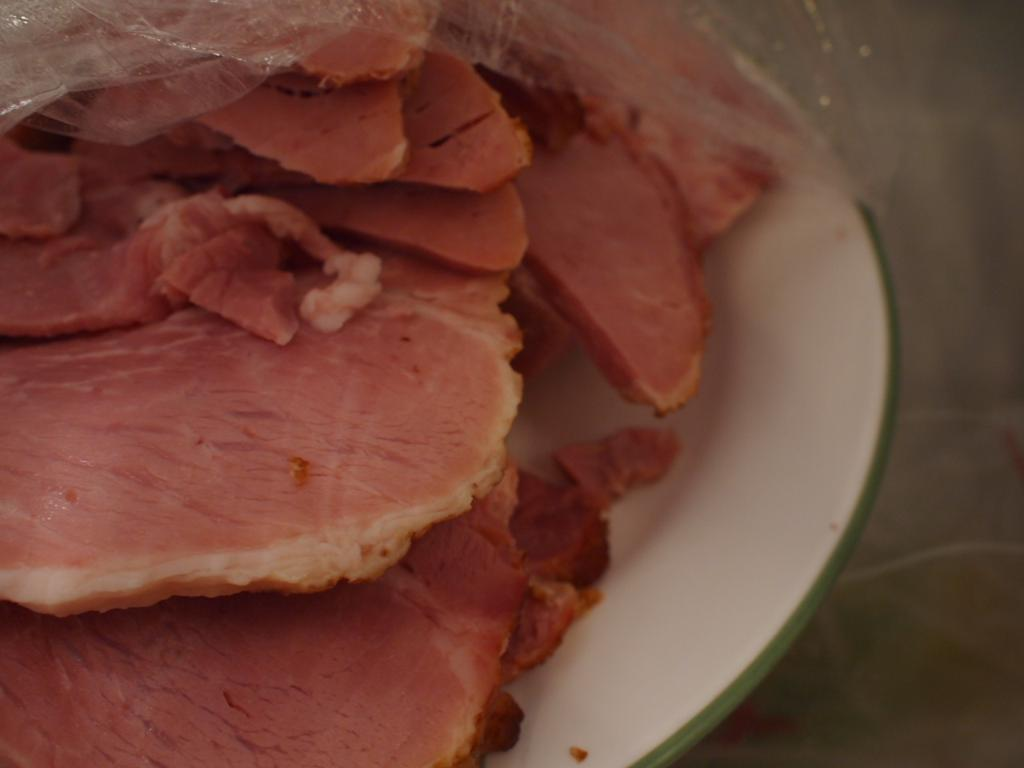What is on the plate that is visible in the image? There is a plate with food in the image. Is there anything covering the food on the plate? Yes, there is a cover on the plate. What type of button is the minister wearing in the image? There is no minister or button present in the image; it only features a plate with food and a cover on it. 